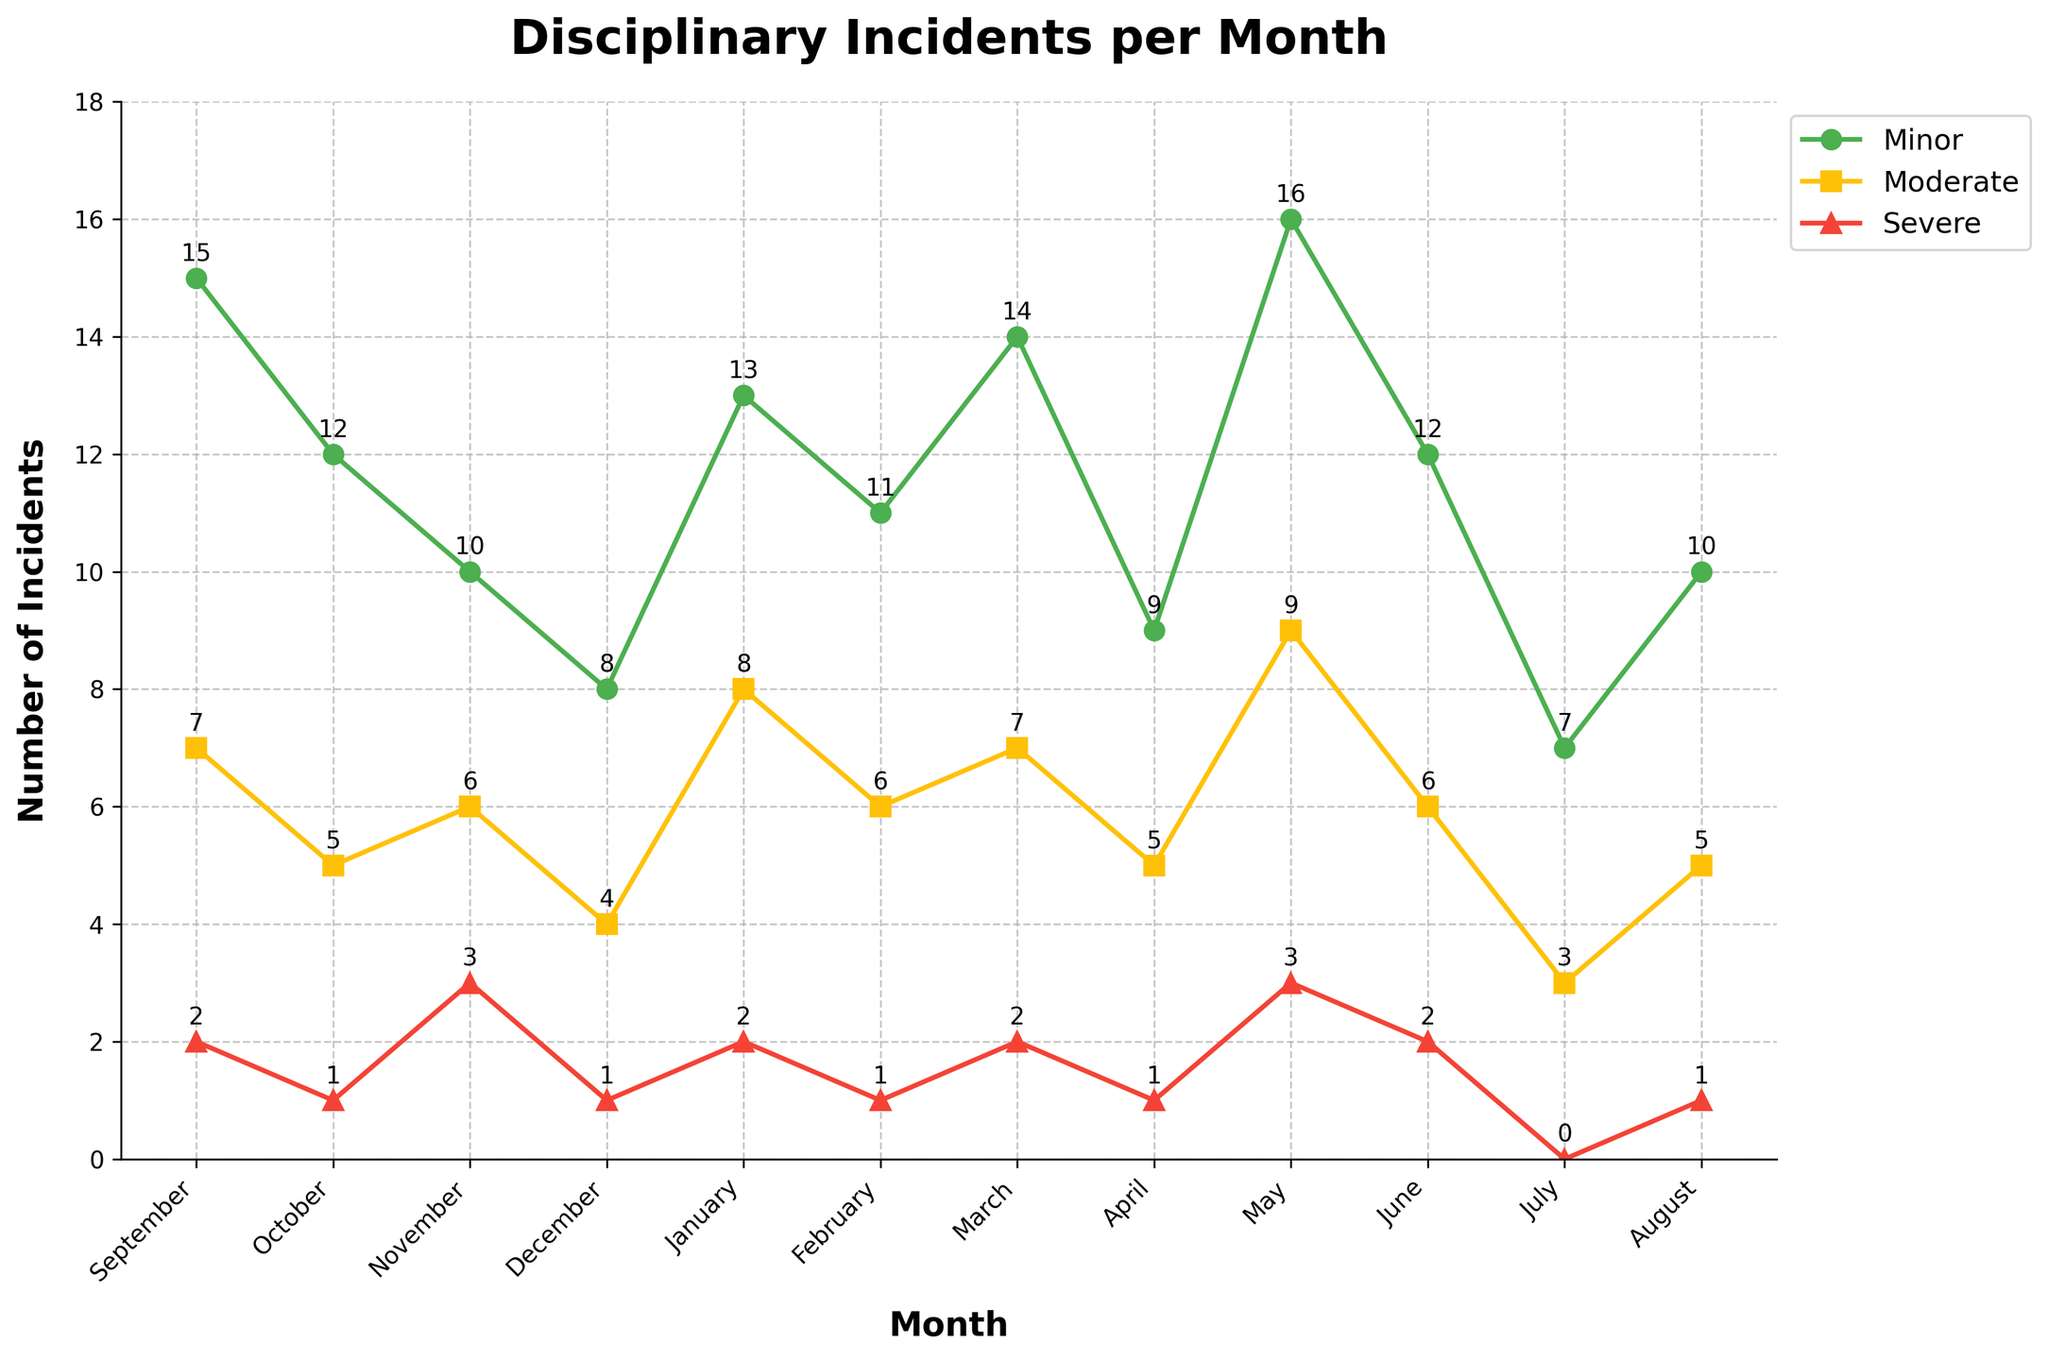Which month had the highest number of minor incidents? By looking at the graph and finding the highest peak line representing minor incidents (green line), we see that it occurs in May.
Answer: May How many severe incidents were there from January to June? Summing the severe incidents for each month from January to June: 2 (Jan) + 1 (Feb) + 2 (Mar) + 1 (Apr) + 3 (May) + 2 (Jun) = 11.
Answer: 11 Which months had equal minor and moderate incidents? By looking at both the green and yellow lines, the months with points at the same height are February and April.
Answer: February, April Compare the number of moderate incidents in September and May. Which has more? Checking the heights of the yellow line in September (7) and May (9), we see that May has more moderate incidents.
Answer: May How did the number of severe incidents change from December to January? December has 1 severe incident, while January has 2; thus, there is an increase of 1 incident.
Answer: Increased by 1 Which category of incidents shows the most fluctuation throughout the year? Evaluating the lines indicates that the minor incidents (green line) vary the most, with peaks in May and troughs in July.
Answer: Minor What is the total number of incidents in November across all categories? Summing the incidents in November: 10 (minor) + 6 (moderate) + 3 (severe) = 19.
Answer: 19 Which category has the least number of incidents in July? Observing all lines in July, the severe category (red line) has the least with 0 incidents.
Answer: Severe What is the average number of moderate incidents per month? Sum of moderate incidents (7+5+6+4+8+6+7+5+9+6+3+5) = 71; divided by 12 months is approximately 71/12 ≈ 5.92.
Answer: 5.92 How many more minor incidents were there in May compared to June? Minor incidents in May: 16; in June: 12; the difference is 16 - 12 = 4.
Answer: 4 